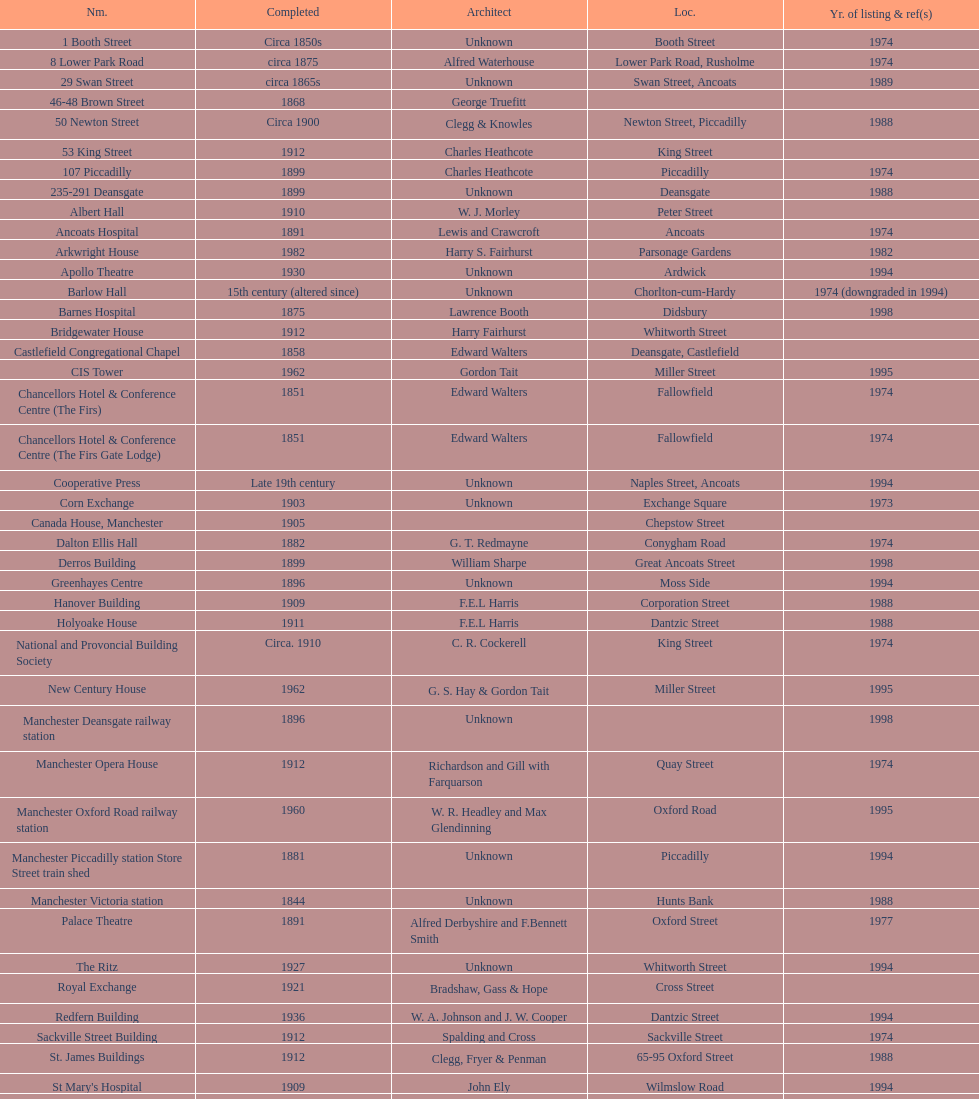How many buildings has the same year of listing as 1974? 15. 